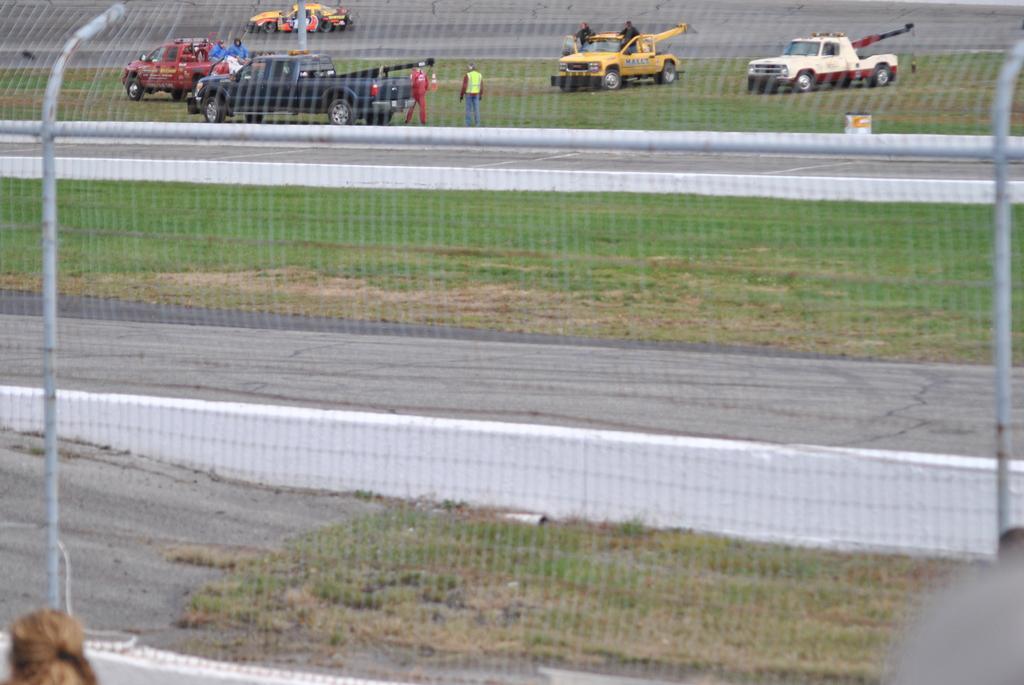Describe this image in one or two sentences. There is a net with poles. In the back there are many vehicles and people. On the ground there is grass. 